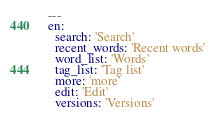Convert code to text. <code><loc_0><loc_0><loc_500><loc_500><_YAML_>---
en:
  search: 'Search'
  recent_words: 'Recent words'
  word_list: 'Words'
  tag_list: 'Tag list'
  more: 'more'
  edit: 'Edit'
  versions: 'Versions'
</code> 